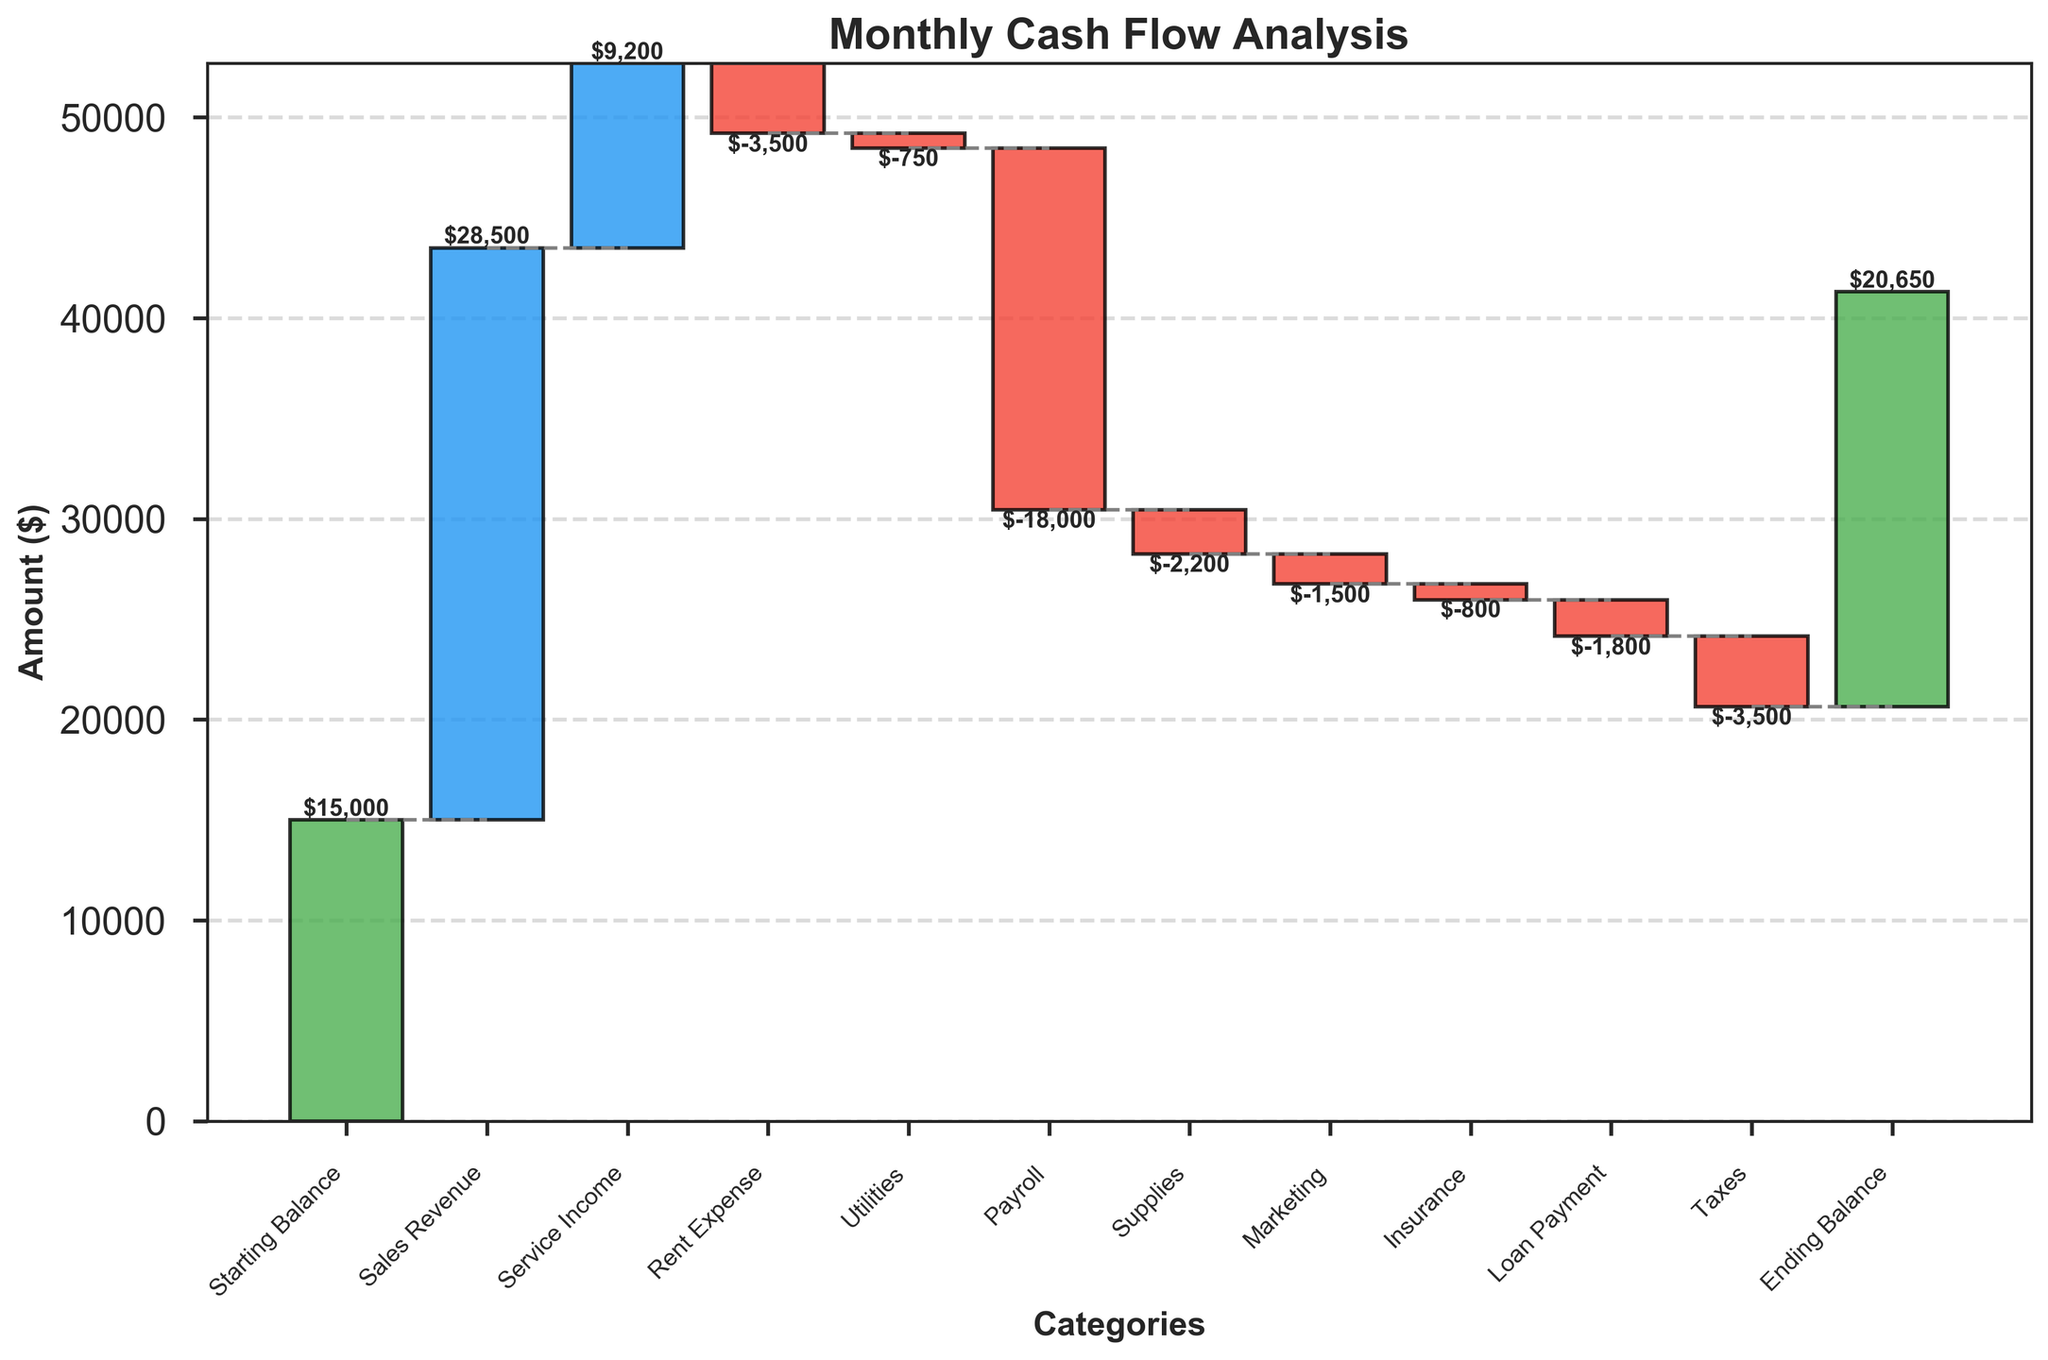What is the title of the chart? The title of the chart is at the top and it reads "Monthly Cash Flow Analysis."
Answer: Monthly Cash Flow Analysis How is the ending balance determined in the chart? The ending balance is determined by adding the starting balance and all cash inflow amounts, then subtracting all cash outflow amounts. Specifically, add sales revenue and service income to the starting balance, then subtract expenses like rent, utilities, payroll, and others to arrive at the ending balance.
Answer: $20,650 What category has the highest cash inflow? By examining the height of the blue bars in the chart, the highest cash inflow category is Sales Revenue.
Answer: Sales Revenue Which two categories have the highest expenses? By looking at the tallest red bars representing negative amounts, Payroll and Taxes have the highest expenses.
Answer: Payroll and Taxes What is the net result of all expenses combined? Sum the negative amounts (-$3500 for Rent, -$750 for Utilities, -$18000 for Payroll, -$2200 for Supplies, -$1500 for Marketing, -$800 for Insurance, -$1800 for Loan Payment, and -$3500 for Taxes): -$3500 - $750 - $18000 - $2200 - $1500 - $800 - $1800 - $3500 = -$30,050
Answer: -$30,050 How does the ending balance compare to the initial balance? The starting balance is $15,000 and the ending balance is $20,650. The ending balance is higher than the starting balance.
Answer: The ending balance is higher What is the total cash inflow for the month? Add up all positive amounts: $28,500 (Sales Revenue) + $9,200 (Service Income) = $37,700.
Answer: $37,700 How much was spent on payroll? Look for the Payroll negative bar, which is labeled as -$18,000.
Answer: $18,000 Which category has the smallest amount of expense? The smallest negative bar represents Utilities, which is labeled as -$750.
Answer: Utilities What is the difference between the total sales revenue and total taxes paid? Total Sales Revenue is $28,500 and total Taxes paid are $3,500. Subtract Taxes from Sales Revenue: $28,500 - $3,500 = $25,000.
Answer: $25,000 